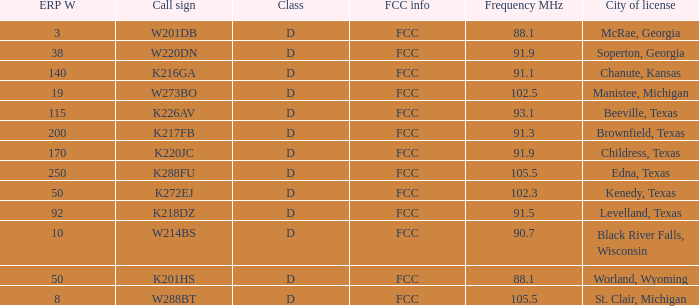What is City of License, when ERP W is greater than 3, and when Call Sign is K218DZ? Levelland, Texas. 